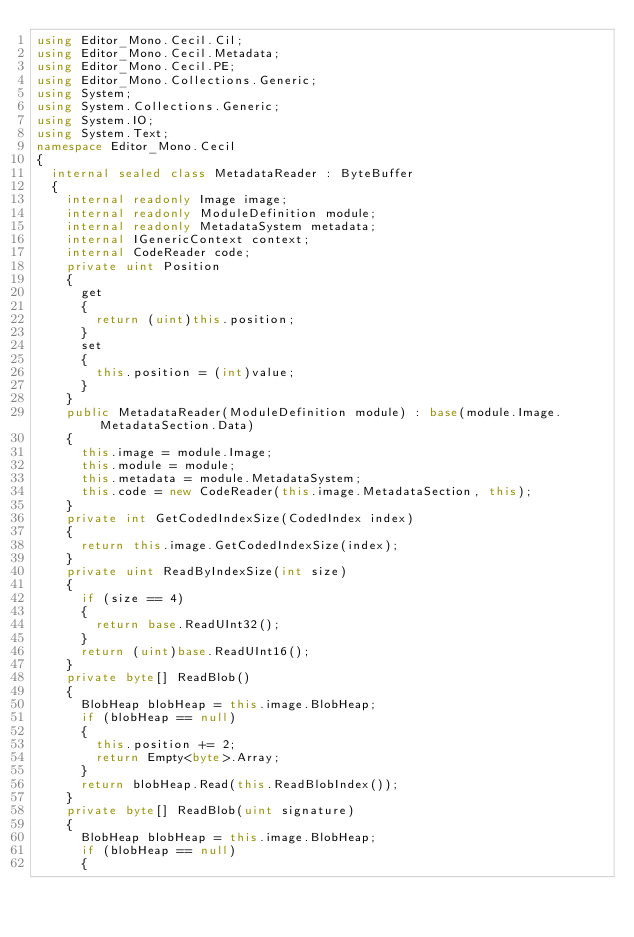Convert code to text. <code><loc_0><loc_0><loc_500><loc_500><_C#_>using Editor_Mono.Cecil.Cil;
using Editor_Mono.Cecil.Metadata;
using Editor_Mono.Cecil.PE;
using Editor_Mono.Collections.Generic;
using System;
using System.Collections.Generic;
using System.IO;
using System.Text;
namespace Editor_Mono.Cecil
{
	internal sealed class MetadataReader : ByteBuffer
	{
		internal readonly Image image;
		internal readonly ModuleDefinition module;
		internal readonly MetadataSystem metadata;
		internal IGenericContext context;
		internal CodeReader code;
		private uint Position
		{
			get
			{
				return (uint)this.position;
			}
			set
			{
				this.position = (int)value;
			}
		}
		public MetadataReader(ModuleDefinition module) : base(module.Image.MetadataSection.Data)
		{
			this.image = module.Image;
			this.module = module;
			this.metadata = module.MetadataSystem;
			this.code = new CodeReader(this.image.MetadataSection, this);
		}
		private int GetCodedIndexSize(CodedIndex index)
		{
			return this.image.GetCodedIndexSize(index);
		}
		private uint ReadByIndexSize(int size)
		{
			if (size == 4)
			{
				return base.ReadUInt32();
			}
			return (uint)base.ReadUInt16();
		}
		private byte[] ReadBlob()
		{
			BlobHeap blobHeap = this.image.BlobHeap;
			if (blobHeap == null)
			{
				this.position += 2;
				return Empty<byte>.Array;
			}
			return blobHeap.Read(this.ReadBlobIndex());
		}
		private byte[] ReadBlob(uint signature)
		{
			BlobHeap blobHeap = this.image.BlobHeap;
			if (blobHeap == null)
			{</code> 